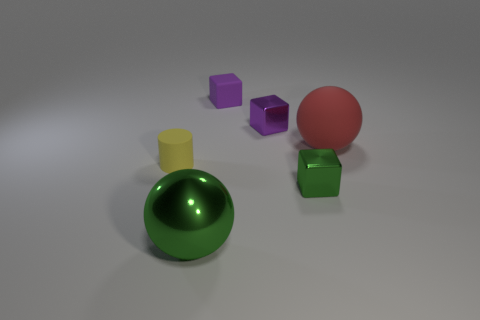Is there any other thing that is the same shape as the yellow object?
Your answer should be very brief. No. There is a purple block that is in front of the rubber cube; is its size the same as the yellow rubber object?
Keep it short and to the point. Yes. The matte object that is on the right side of the large green metallic object and on the left side of the big red ball has what shape?
Make the answer very short. Cube. Is the number of blocks that are left of the green metallic block greater than the number of red spheres?
Your response must be concise. Yes. What size is the ball that is made of the same material as the tiny green cube?
Give a very brief answer. Large. What number of metal things have the same color as the tiny rubber cube?
Your response must be concise. 1. There is a small shiny cube that is behind the red object; is it the same color as the small matte cube?
Provide a short and direct response. Yes. Is the number of red rubber things that are in front of the green metallic cube the same as the number of things behind the large matte sphere?
Your answer should be compact. No. What color is the small metal object in front of the tiny purple shiny block?
Give a very brief answer. Green. Are there the same number of red things that are in front of the yellow cylinder and small gray matte balls?
Provide a succinct answer. Yes. 